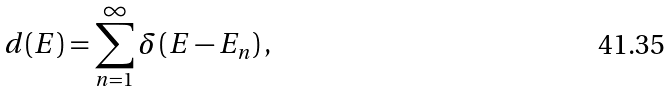<formula> <loc_0><loc_0><loc_500><loc_500>d ( E ) = \sum _ { n = 1 } ^ { \infty } \delta \left ( E - E _ { n } \right ) ,</formula> 